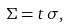Convert formula to latex. <formula><loc_0><loc_0><loc_500><loc_500>\Sigma = t \, \sigma ,</formula> 